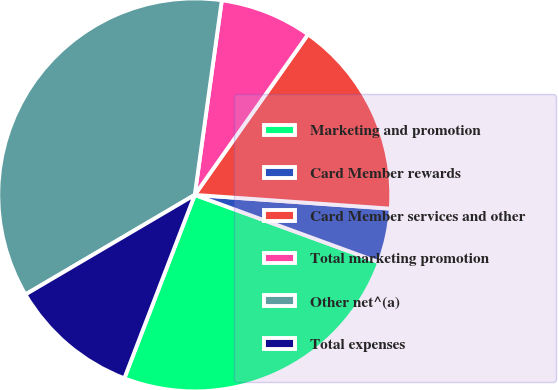Convert chart to OTSL. <chart><loc_0><loc_0><loc_500><loc_500><pie_chart><fcel>Marketing and promotion<fcel>Card Member rewards<fcel>Card Member services and other<fcel>Total marketing promotion<fcel>Other net^(a)<fcel>Total expenses<nl><fcel>25.26%<fcel>4.46%<fcel>16.34%<fcel>7.58%<fcel>35.66%<fcel>10.7%<nl></chart> 